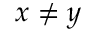Convert formula to latex. <formula><loc_0><loc_0><loc_500><loc_500>x \neq y</formula> 